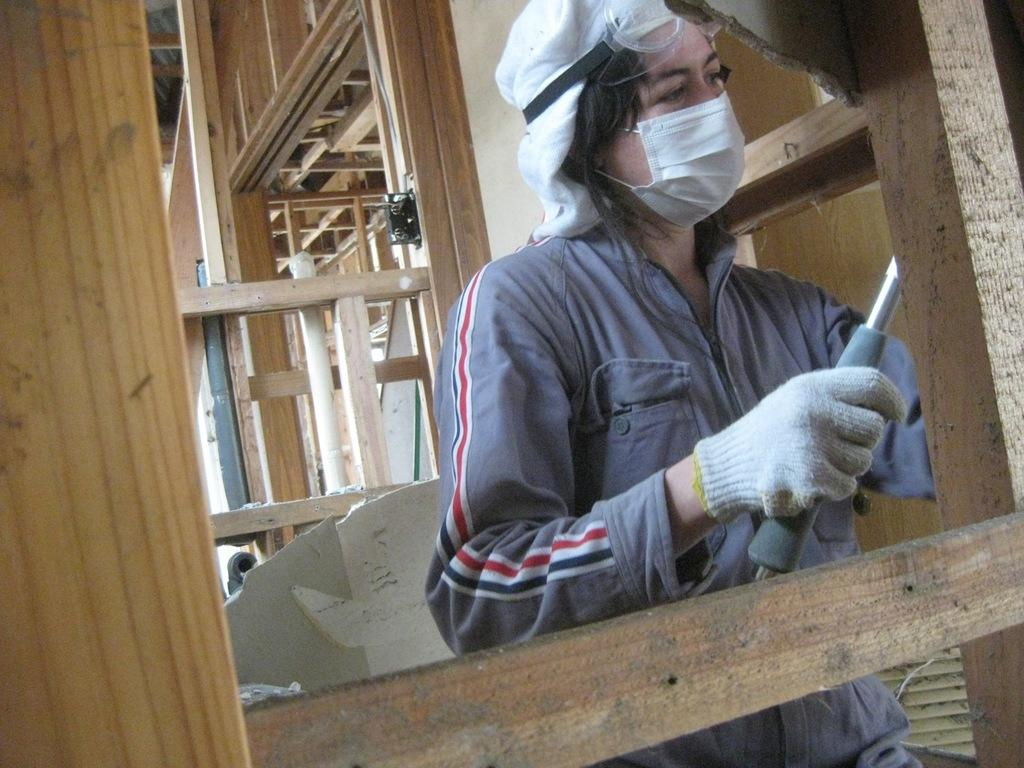What is the person in the image doing? The person is standing and holding a metal rod in the image. What objects can be seen in the image besides the person? There are wooden frames and a fan in the image. What type of surface is visible in the image? There is a wall in the image. How many tomatoes are being measured by the person in the image? There are no tomatoes present in the image, and the person is not measuring anything. 